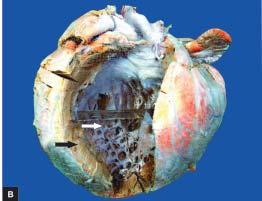s the free left ventricular wall thickened hypertrophy with dilatation?
Answer the question using a single word or phrase. Yes 